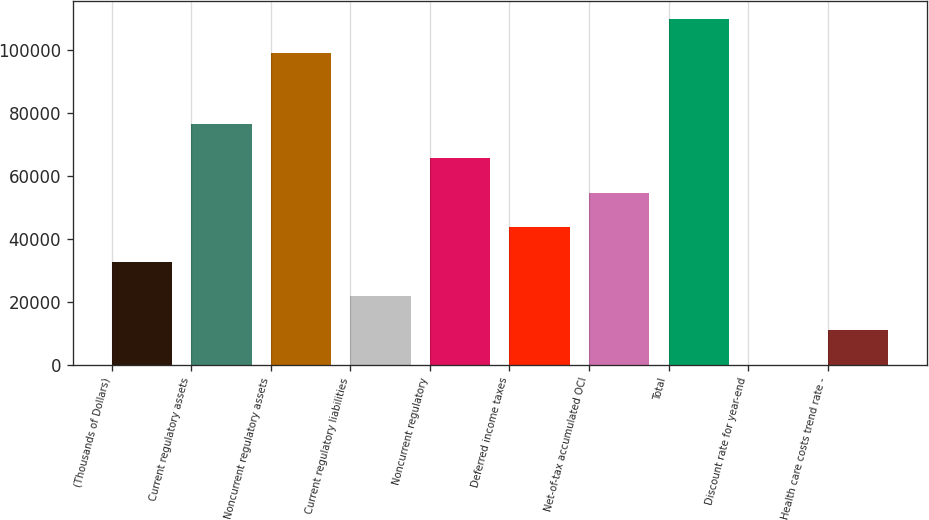<chart> <loc_0><loc_0><loc_500><loc_500><bar_chart><fcel>(Thousands of Dollars)<fcel>Current regulatory assets<fcel>Noncurrent regulatory assets<fcel>Current regulatory liabilities<fcel>Noncurrent regulatory<fcel>Deferred income taxes<fcel>Net-of-tax accumulated OCI<fcel>Total<fcel>Discount rate for year-end<fcel>Health care costs trend rate -<nl><fcel>32803.6<fcel>76535.3<fcel>99071<fcel>21870.7<fcel>65602.3<fcel>43736.5<fcel>54669.4<fcel>110004<fcel>4.82<fcel>10937.7<nl></chart> 